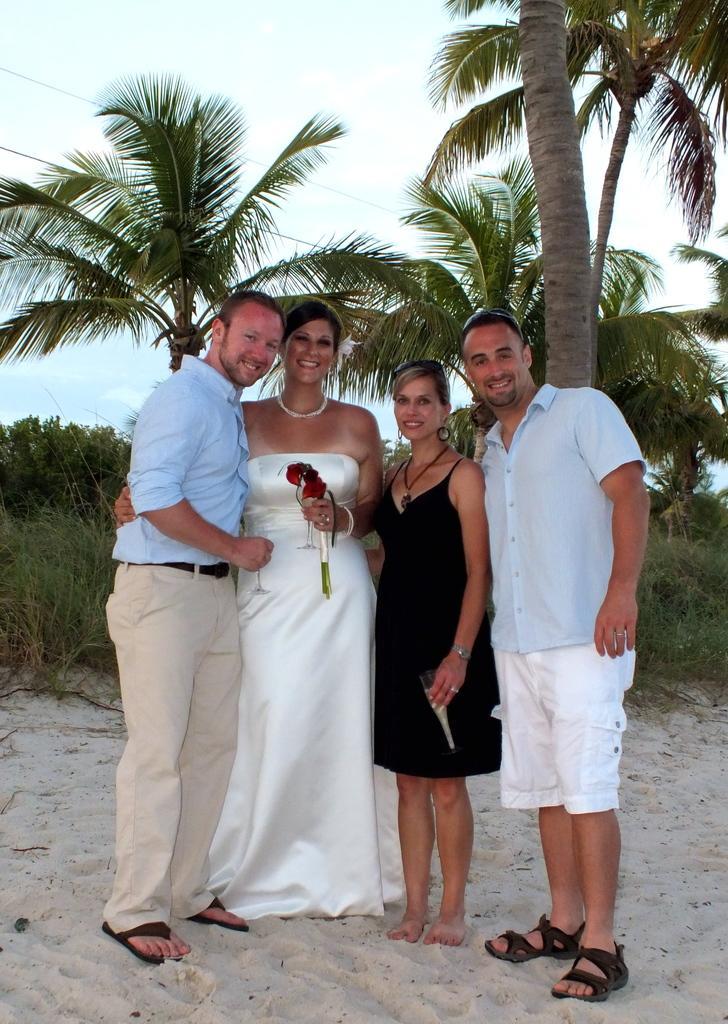Describe this image in one or two sentences. There are people standing and smiling, she is holding flowers. We can see sand. In the background we can see trees, grass, plants and sky. 